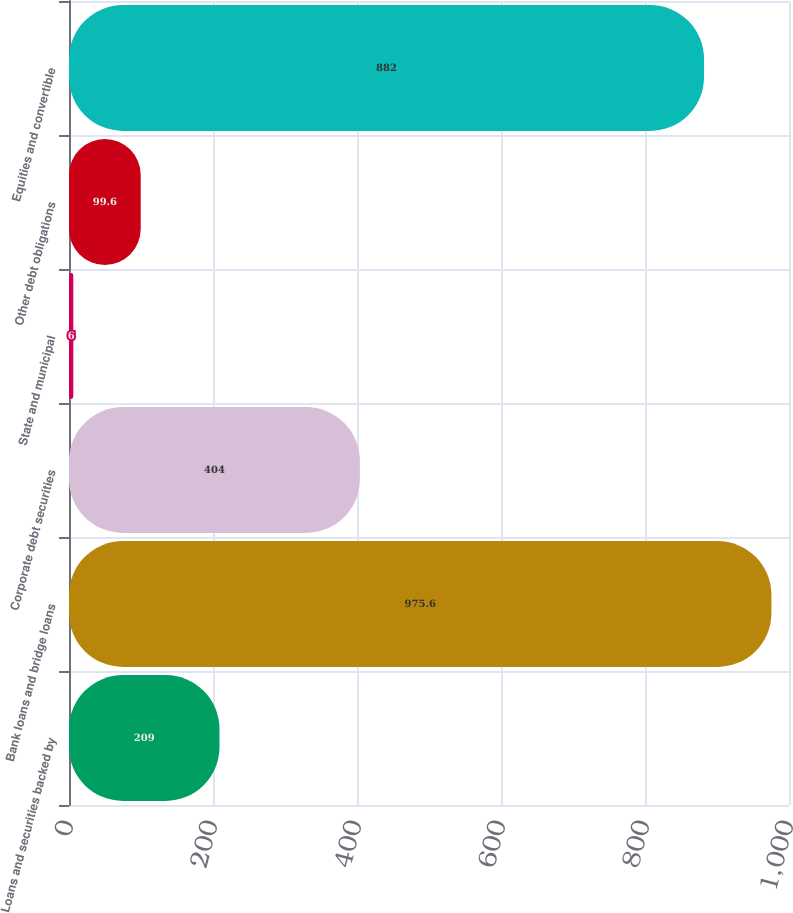Convert chart to OTSL. <chart><loc_0><loc_0><loc_500><loc_500><bar_chart><fcel>Loans and securities backed by<fcel>Bank loans and bridge loans<fcel>Corporate debt securities<fcel>State and municipal<fcel>Other debt obligations<fcel>Equities and convertible<nl><fcel>209<fcel>975.6<fcel>404<fcel>6<fcel>99.6<fcel>882<nl></chart> 